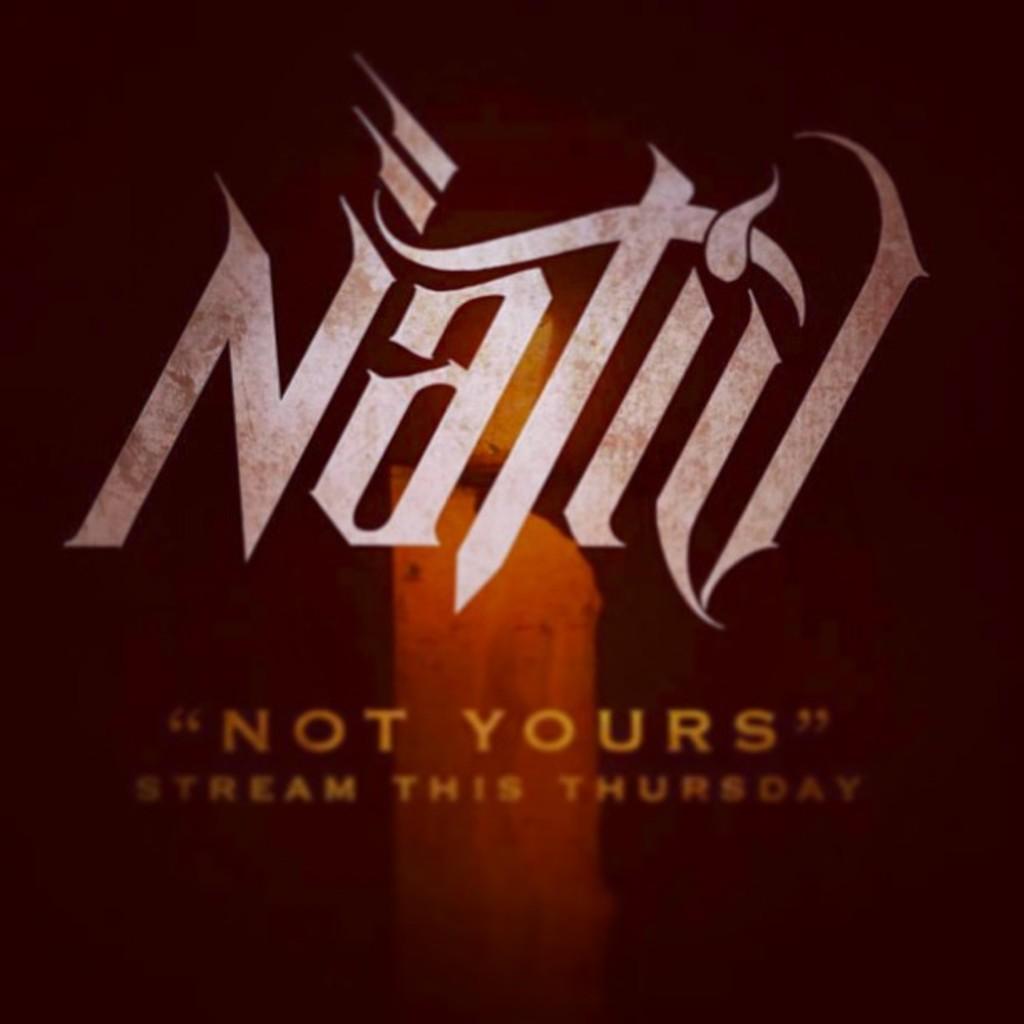What day is it available to stream?
Your answer should be compact. Thursday. What is the name of the band?
Keep it short and to the point. Nativ. 